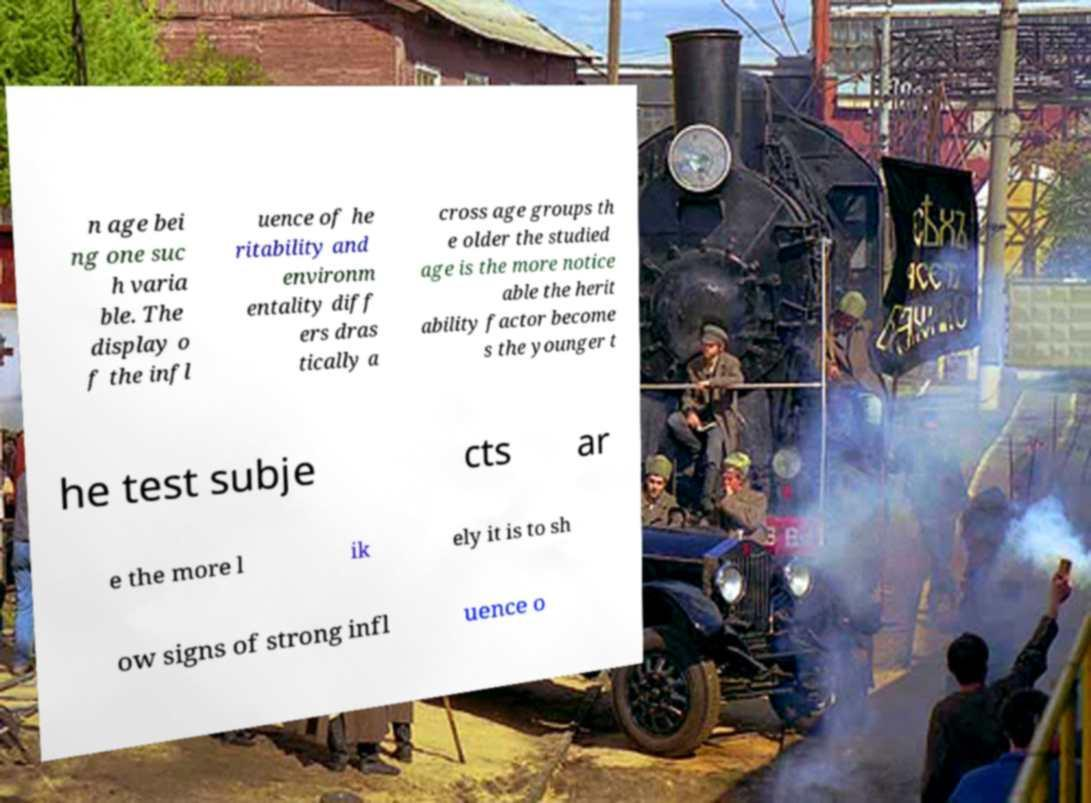Can you read and provide the text displayed in the image?This photo seems to have some interesting text. Can you extract and type it out for me? n age bei ng one suc h varia ble. The display o f the infl uence of he ritability and environm entality diff ers dras tically a cross age groups th e older the studied age is the more notice able the herit ability factor become s the younger t he test subje cts ar e the more l ik ely it is to sh ow signs of strong infl uence o 